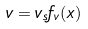Convert formula to latex. <formula><loc_0><loc_0><loc_500><loc_500>v = v _ { s } f _ { v } ( x ) \quad</formula> 